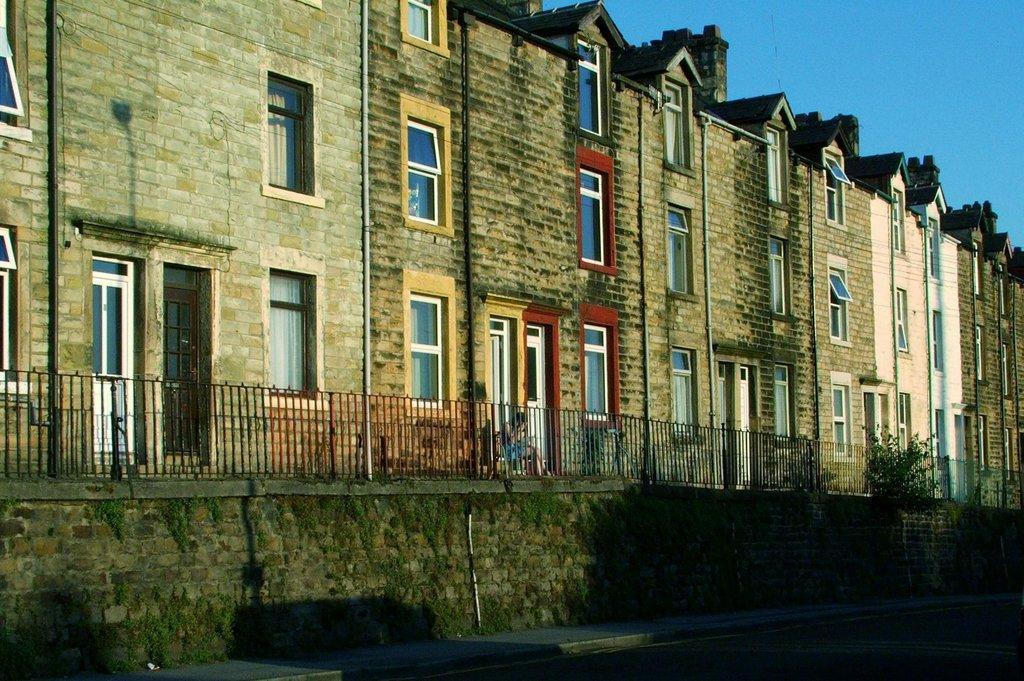Could you give a brief overview of what you see in this image? In the center of the image we can see buildings, windows, doors, pipes, wall, roof, grills, persons, plants. At the bottom of the image there is a ground. At the top of the image there is a sky. 